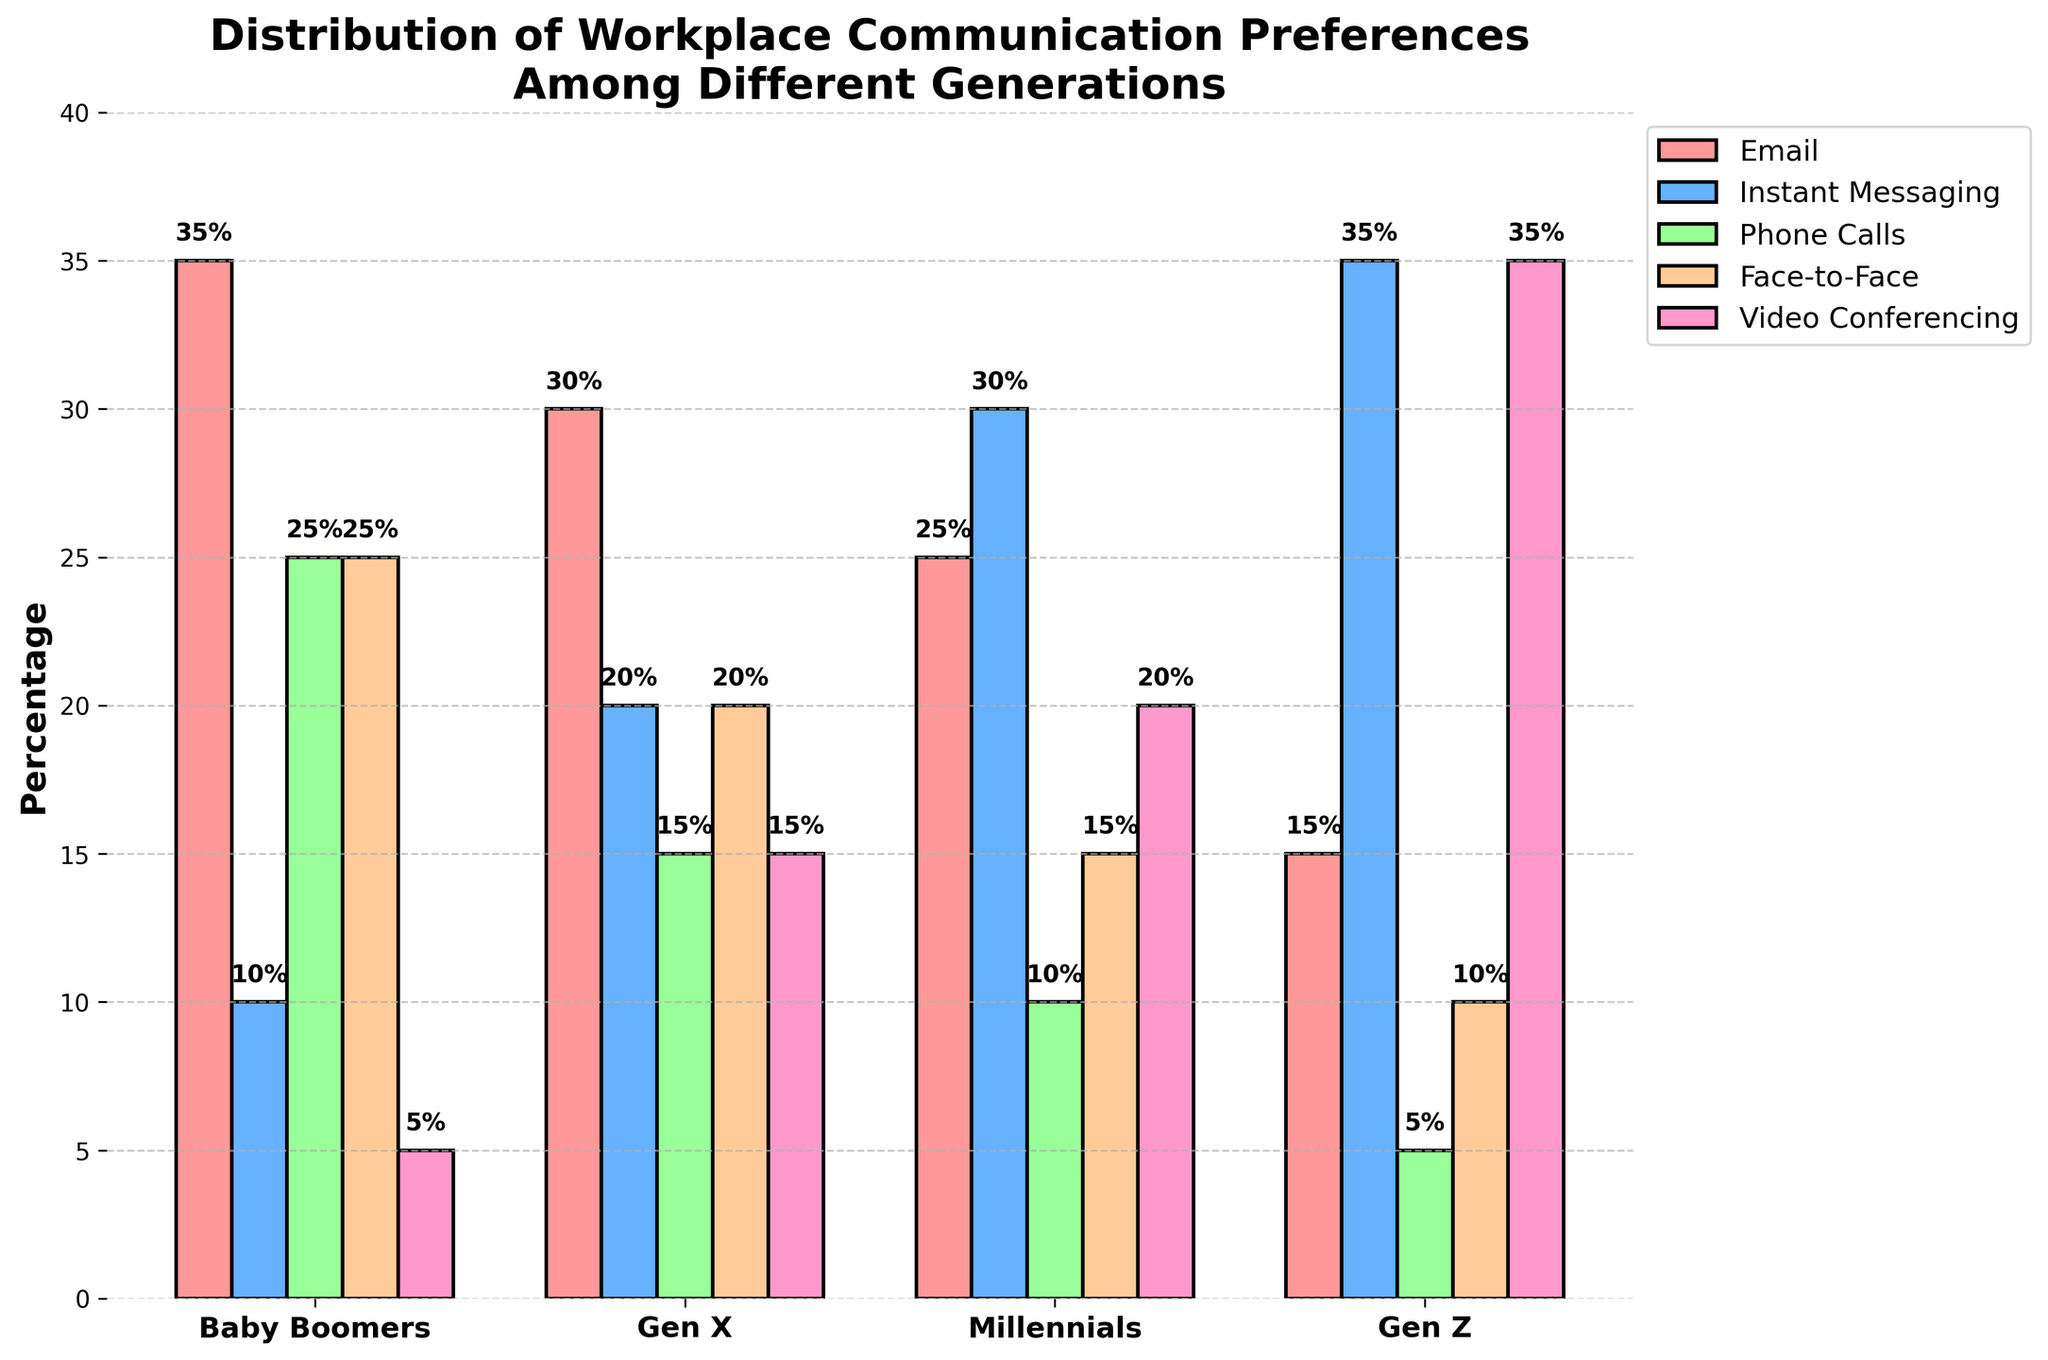What is the preferred communication method for Gen Z? Gen Z prefers Video Conferencing the most, as indicated by the tallest bar among the other communication methods for this generation.
Answer: Video Conferencing Which generation prefers Face-to-Face communication the least? Gen Z has the smallest bar for Face-to-Face communication at 10%, compared to Baby Boomers at 25%, Gen X at 20%, and Millennials at 15%.
Answer: Gen Z How do the Email preferences of Baby Boomers and Millennials compare? Baby Boomers prefer Email at 35% while Millennials prefer it at 25%. Baby Boomers have a higher preference for Email than Millennials.
Answer: Baby Boomers prefer Email more What is the average preference percentage for Instant Messaging across all generations? Summing the Instant Messaging percentages: 10% (Baby Boomers) + 20% (Gen X) + 30% (Millennials) + 35% (Gen Z) = 95%. Dividing by 4 gives the average: 95% / 4 = 23.75%.
Answer: 23.75% Which communication method is preferred equally by two different generations, and which generations are these? The preference for Face-to-Face communication is the same for Baby Boomers and Millennials at 25%.
Answer: Face-to-Face, Baby Boomers and Millennials What is the total percentage of preference for Phone Calls across all generations? Adding the Phone Calls percentages: 25% (Baby Boomers) + 15% (Gen X) + 10% (Millennials) + 5% (Gen Z) = 55%
Answer: 55% By how much does the preference for Video Conferencing differ between Millennials and Gen Z? Gen Z prefers Video Conferencing at 35%, while Millennials prefer it at 20%. The difference is 35% - 20% = 15%.
Answer: 15% What is the median preference percentage for Face-to-Face communication among the generations? The Face-to-Face percentages are: 25% (Baby Boomers), 20% (Gen X), 15% (Millennials), 10% (Gen Z). Arranging in increasing order: 10%, 15%, 20%, 25%, the median is the average of the two middle values: (15% + 20%) / 2 = 17.5%.
Answer: 17.5% Which generation has the highest combined preference for Email and Instant Messaging, and what is the combined percentage? Calculating combined percentages: Baby Boomers: 35% + 10% = 45%; Gen X: 30% + 20% = 50%; Millennials: 25% + 30% = 55%; Gen Z: 15% + 35% = 50%. Millennials have the highest combined preference at 55%.
Answer: Millennials, 55% Between which two communication methods does Baby Boomers have the smallest difference in preference percentage, and what is the difference? Baby Boomers have 25% preference for both Phone Calls and Face-to-Face, so the difference is 0%.
Answer: Phone Calls and Face-to-Face, 0% 